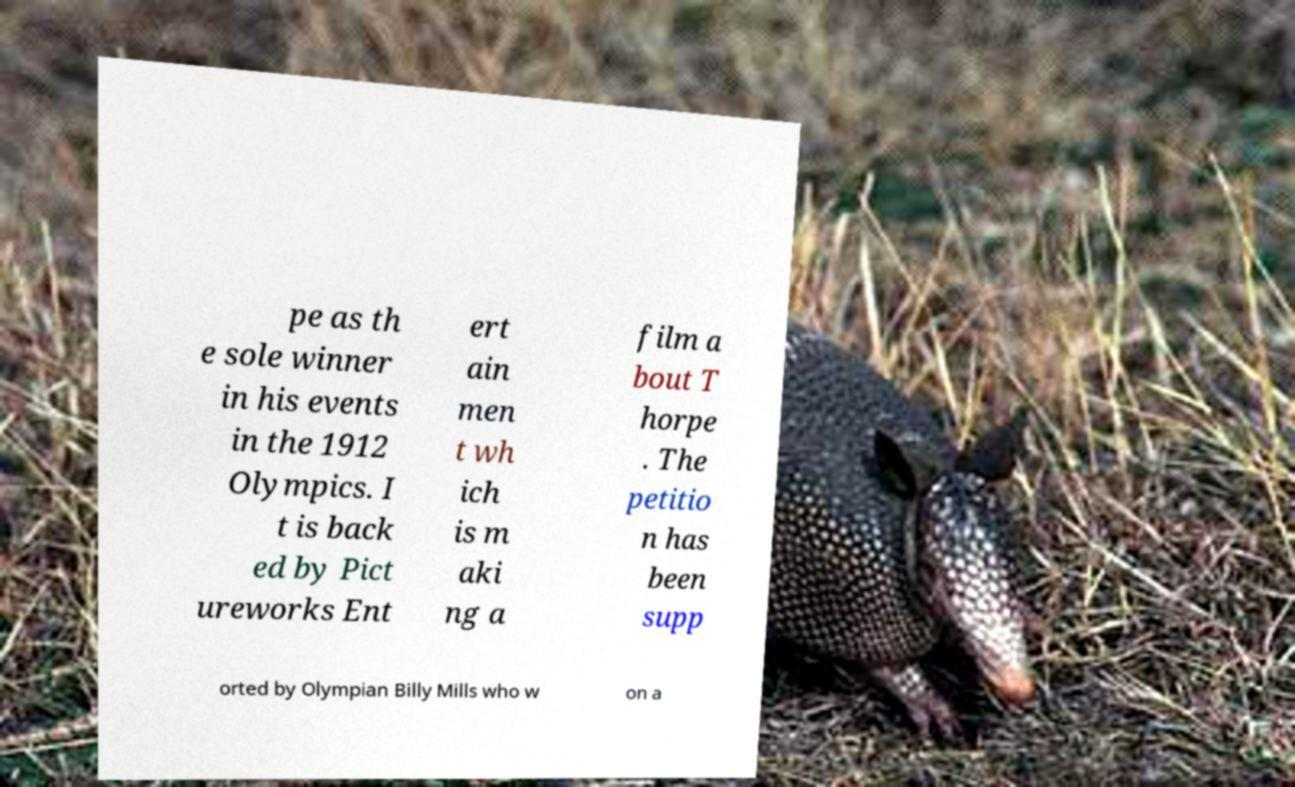Please identify and transcribe the text found in this image. pe as th e sole winner in his events in the 1912 Olympics. I t is back ed by Pict ureworks Ent ert ain men t wh ich is m aki ng a film a bout T horpe . The petitio n has been supp orted by Olympian Billy Mills who w on a 